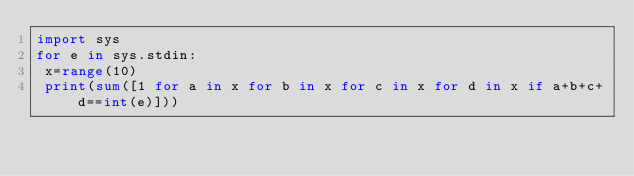Convert code to text. <code><loc_0><loc_0><loc_500><loc_500><_Python_>import sys
for e in sys.stdin:
 x=range(10)
 print(sum([1 for a in x for b in x for c in x for d in x if a+b+c+d==int(e)]))
</code> 